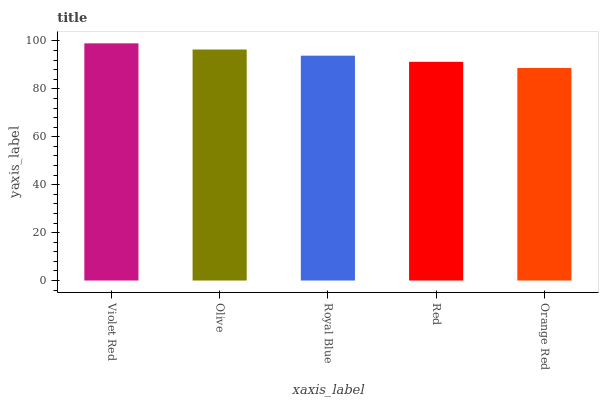Is Orange Red the minimum?
Answer yes or no. Yes. Is Violet Red the maximum?
Answer yes or no. Yes. Is Olive the minimum?
Answer yes or no. No. Is Olive the maximum?
Answer yes or no. No. Is Violet Red greater than Olive?
Answer yes or no. Yes. Is Olive less than Violet Red?
Answer yes or no. Yes. Is Olive greater than Violet Red?
Answer yes or no. No. Is Violet Red less than Olive?
Answer yes or no. No. Is Royal Blue the high median?
Answer yes or no. Yes. Is Royal Blue the low median?
Answer yes or no. Yes. Is Red the high median?
Answer yes or no. No. Is Olive the low median?
Answer yes or no. No. 